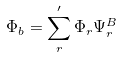Convert formula to latex. <formula><loc_0><loc_0><loc_500><loc_500>\Phi _ { b } = \sum _ { r } ^ { \prime } \Phi _ { r } \Psi _ { r } ^ { B }</formula> 